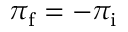Convert formula to latex. <formula><loc_0><loc_0><loc_500><loc_500>\pi _ { f } = - \pi _ { i }</formula> 